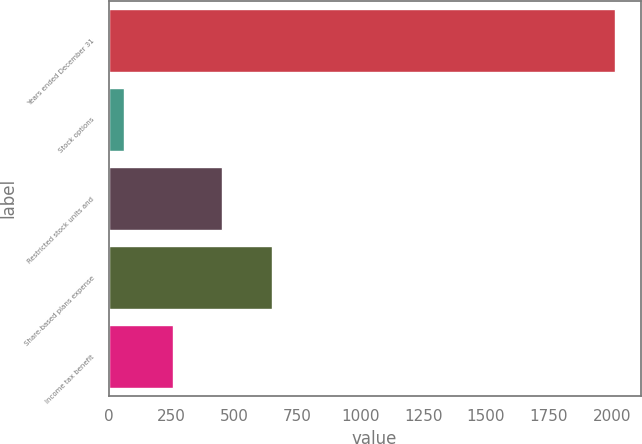Convert chart. <chart><loc_0><loc_0><loc_500><loc_500><bar_chart><fcel>Years ended December 31<fcel>Stock options<fcel>Restricted stock units and<fcel>Share-based plans expense<fcel>Income tax benefit<nl><fcel>2014<fcel>62<fcel>452.4<fcel>647.6<fcel>257.2<nl></chart> 